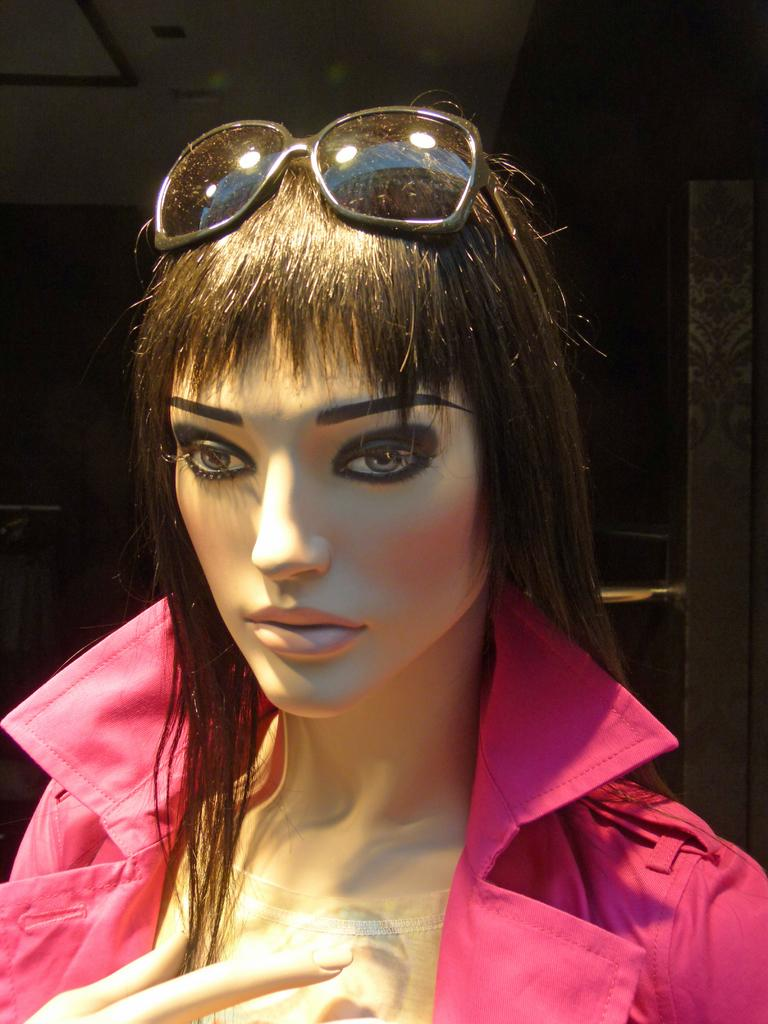What is the main subject of the image? There is a mannequin in the image. What is the mannequin wearing? The mannequin is wearing a pink coat. What can be seen above the mannequin in the image? There is a roof visible in the image. How would you describe the lighting in the image? The background of the image is dark. What type of knife can be seen in the mannequin's hand in the image? There is no knife present in the image, and the mannequin does not have any hands. 